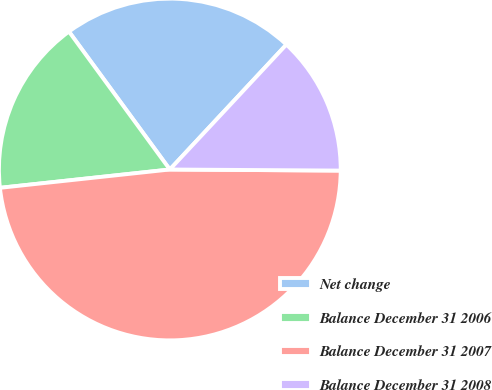<chart> <loc_0><loc_0><loc_500><loc_500><pie_chart><fcel>Net change<fcel>Balance December 31 2006<fcel>Balance December 31 2007<fcel>Balance December 31 2008<nl><fcel>22.0%<fcel>16.66%<fcel>48.19%<fcel>13.15%<nl></chart> 